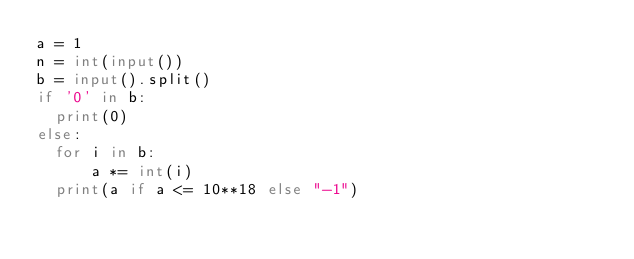<code> <loc_0><loc_0><loc_500><loc_500><_Python_>a = 1
n = int(input())
b = input().split()
if '0' in b:
  print(0)
else:  
  for i in b:
      a *= int(i)
  print(a if a <= 10**18 else "-1")
</code> 